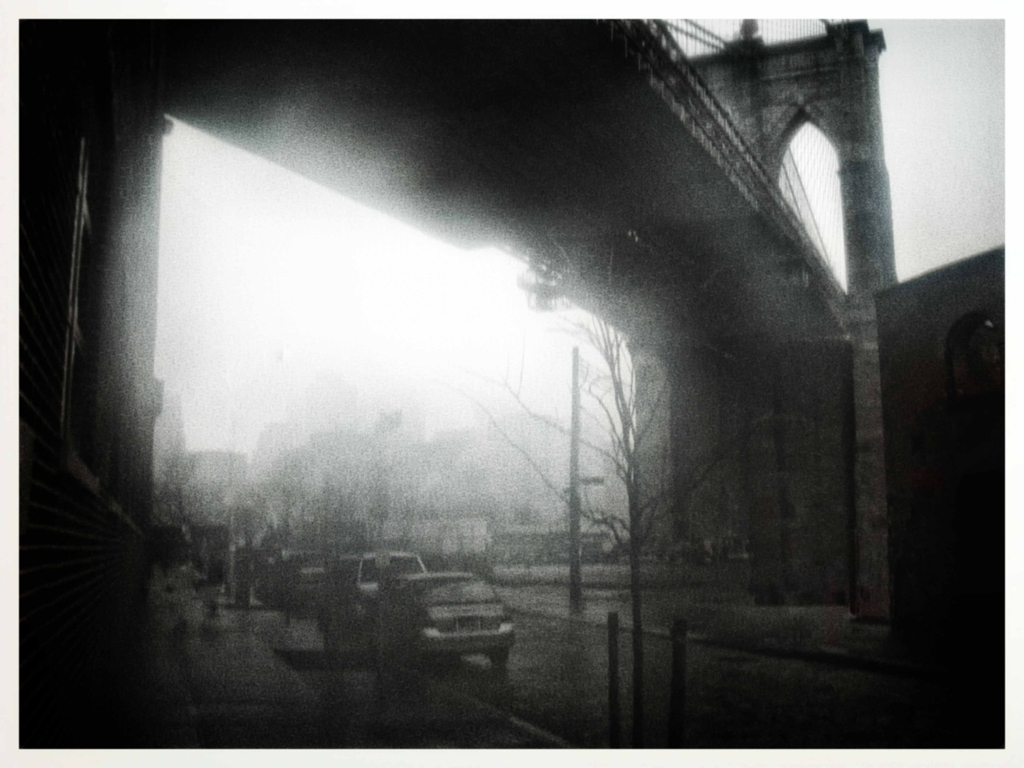Does the image have a wide range of colors? While the image does contain a variety of elements, the overall color palette is quite muted. The scene is dominated by grayscale tones, with the most noticeable colors being the subtle gradations of gray in the sky and the soft browns of the buildings. There is an absence of vibrant or contrasting colors that would indicate a wide range. Therefore, the correct answer is B. No, the image does not have a wide range of colors. 